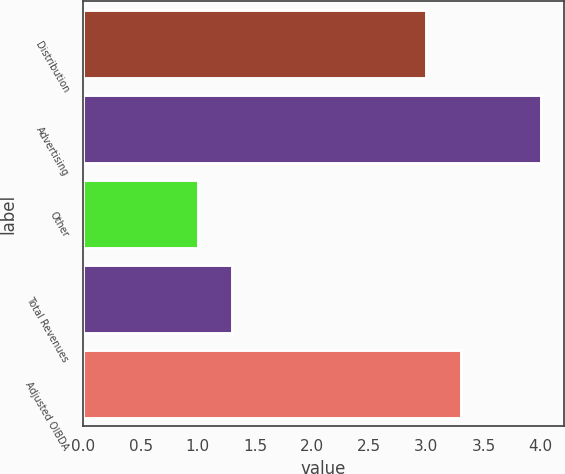Convert chart to OTSL. <chart><loc_0><loc_0><loc_500><loc_500><bar_chart><fcel>Distribution<fcel>Advertising<fcel>Other<fcel>Total Revenues<fcel>Adjusted OIBDA<nl><fcel>3<fcel>4<fcel>1<fcel>1.3<fcel>3.3<nl></chart> 